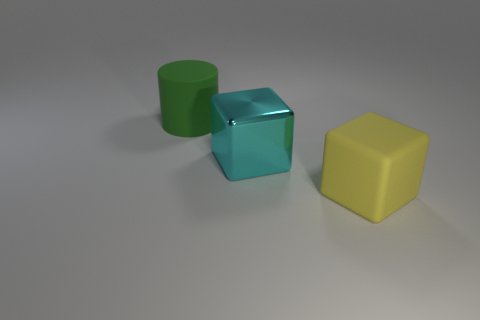Add 3 large cylinders. How many objects exist? 6 Subtract all cylinders. How many objects are left? 2 Subtract all large yellow cubes. Subtract all yellow rubber blocks. How many objects are left? 1 Add 2 big green rubber things. How many big green rubber things are left? 3 Add 2 big yellow matte spheres. How many big yellow matte spheres exist? 2 Subtract 1 yellow blocks. How many objects are left? 2 